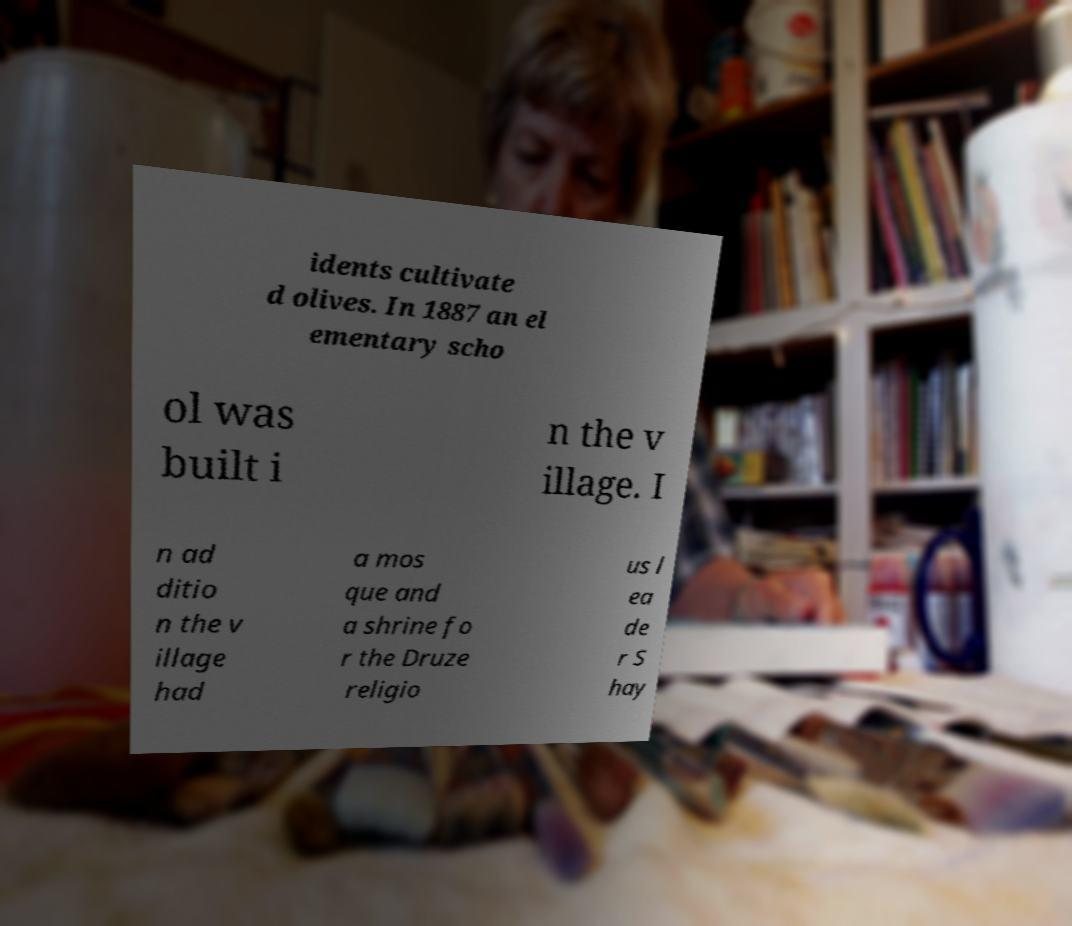Please read and relay the text visible in this image. What does it say? idents cultivate d olives. In 1887 an el ementary scho ol was built i n the v illage. I n ad ditio n the v illage had a mos que and a shrine fo r the Druze religio us l ea de r S hay 